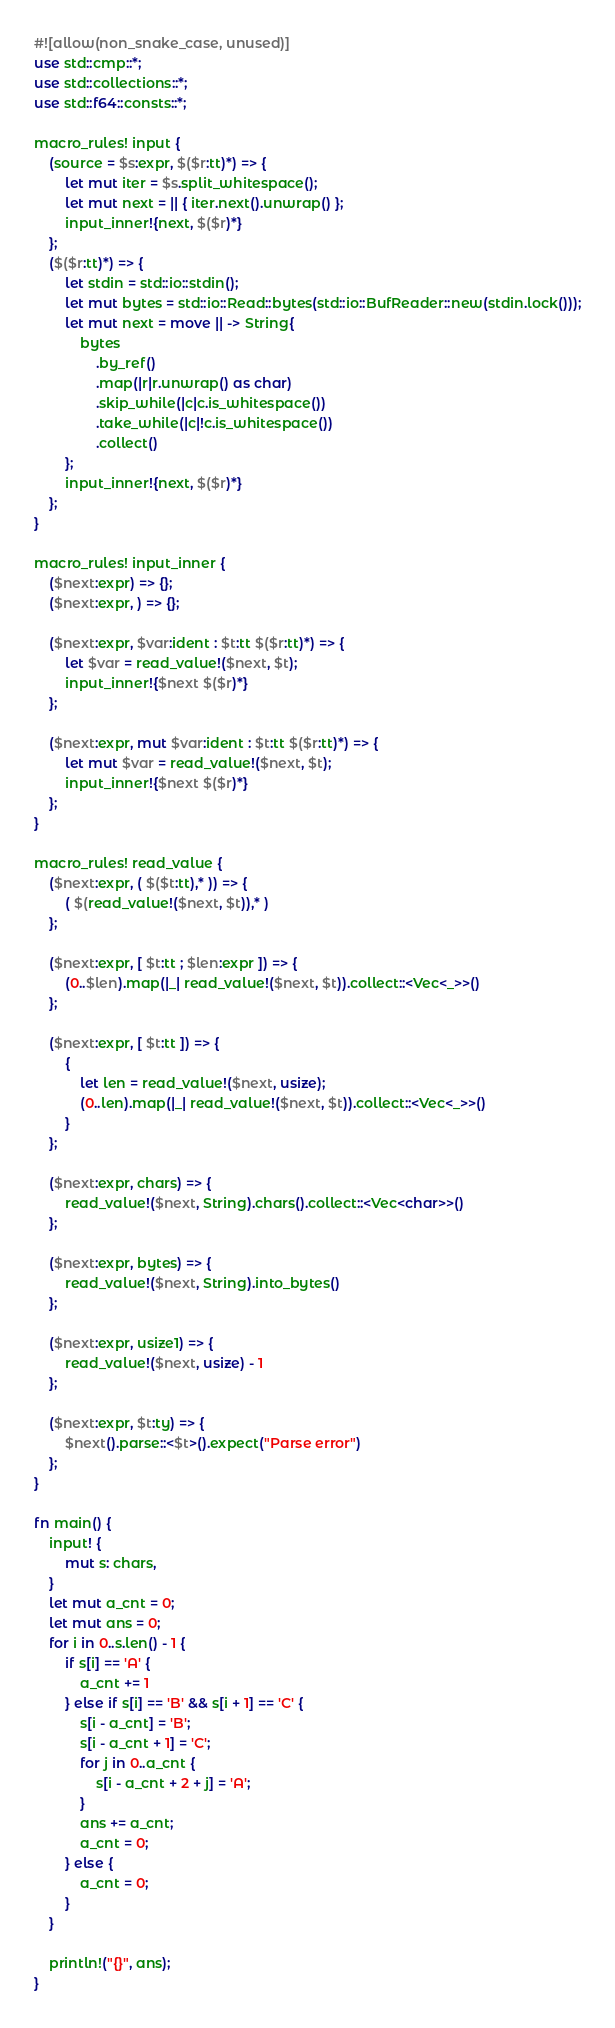<code> <loc_0><loc_0><loc_500><loc_500><_Rust_>#![allow(non_snake_case, unused)]
use std::cmp::*;
use std::collections::*;
use std::f64::consts::*;

macro_rules! input {
    (source = $s:expr, $($r:tt)*) => {
        let mut iter = $s.split_whitespace();
        let mut next = || { iter.next().unwrap() };
        input_inner!{next, $($r)*}
    };
    ($($r:tt)*) => {
        let stdin = std::io::stdin();
        let mut bytes = std::io::Read::bytes(std::io::BufReader::new(stdin.lock()));
        let mut next = move || -> String{
            bytes
                .by_ref()
                .map(|r|r.unwrap() as char)
                .skip_while(|c|c.is_whitespace())
                .take_while(|c|!c.is_whitespace())
                .collect()
        };
        input_inner!{next, $($r)*}
    };
}

macro_rules! input_inner {
    ($next:expr) => {};
    ($next:expr, ) => {};

    ($next:expr, $var:ident : $t:tt $($r:tt)*) => {
        let $var = read_value!($next, $t);
        input_inner!{$next $($r)*}
    };

    ($next:expr, mut $var:ident : $t:tt $($r:tt)*) => {
        let mut $var = read_value!($next, $t);
        input_inner!{$next $($r)*}
    };
}

macro_rules! read_value {
    ($next:expr, ( $($t:tt),* )) => {
        ( $(read_value!($next, $t)),* )
    };

    ($next:expr, [ $t:tt ; $len:expr ]) => {
        (0..$len).map(|_| read_value!($next, $t)).collect::<Vec<_>>()
    };

    ($next:expr, [ $t:tt ]) => {
        {
            let len = read_value!($next, usize);
            (0..len).map(|_| read_value!($next, $t)).collect::<Vec<_>>()
        }
    };

    ($next:expr, chars) => {
        read_value!($next, String).chars().collect::<Vec<char>>()
    };

    ($next:expr, bytes) => {
        read_value!($next, String).into_bytes()
    };

    ($next:expr, usize1) => {
        read_value!($next, usize) - 1
    };

    ($next:expr, $t:ty) => {
        $next().parse::<$t>().expect("Parse error")
    };
}

fn main() {
    input! {
        mut s: chars,
    }
    let mut a_cnt = 0;
    let mut ans = 0;
    for i in 0..s.len() - 1 {
        if s[i] == 'A' {
            a_cnt += 1
        } else if s[i] == 'B' && s[i + 1] == 'C' {
            s[i - a_cnt] = 'B';
            s[i - a_cnt + 1] = 'C';
            for j in 0..a_cnt {
                s[i - a_cnt + 2 + j] = 'A';
            }
            ans += a_cnt;
            a_cnt = 0;
        } else {
            a_cnt = 0;
        }
    }

    println!("{}", ans);
}
</code> 